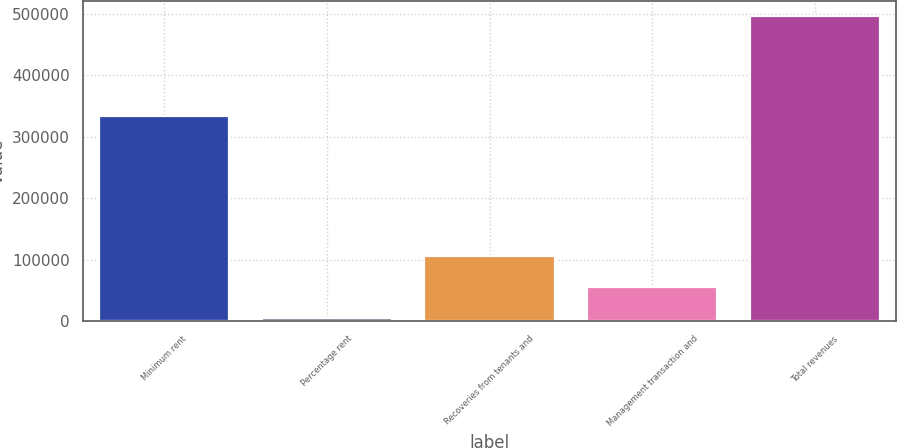Convert chart to OTSL. <chart><loc_0><loc_0><loc_500><loc_500><bar_chart><fcel>Minimum rent<fcel>Percentage rent<fcel>Recoveries from tenants and<fcel>Management transaction and<fcel>Total revenues<nl><fcel>334509<fcel>4258<fcel>105196<fcel>56032<fcel>495895<nl></chart> 